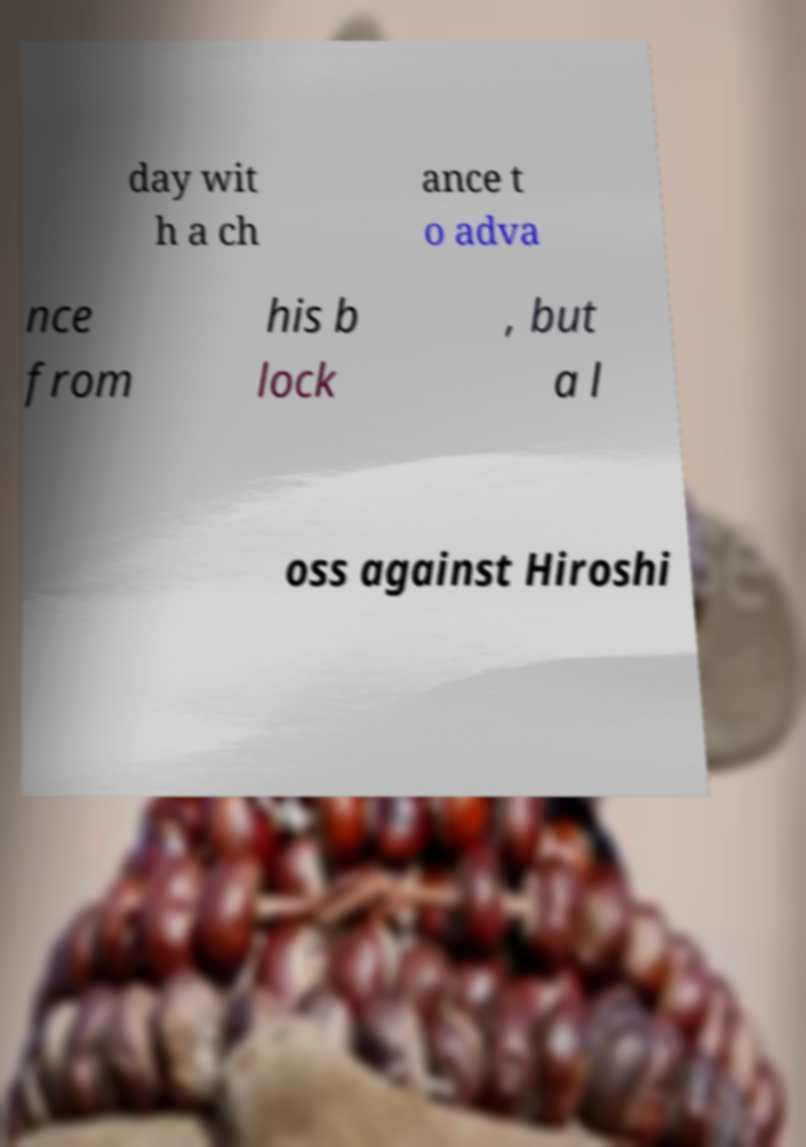Can you accurately transcribe the text from the provided image for me? day wit h a ch ance t o adva nce from his b lock , but a l oss against Hiroshi 